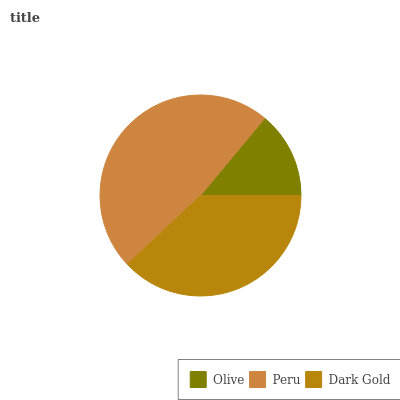Is Olive the minimum?
Answer yes or no. Yes. Is Peru the maximum?
Answer yes or no. Yes. Is Dark Gold the minimum?
Answer yes or no. No. Is Dark Gold the maximum?
Answer yes or no. No. Is Peru greater than Dark Gold?
Answer yes or no. Yes. Is Dark Gold less than Peru?
Answer yes or no. Yes. Is Dark Gold greater than Peru?
Answer yes or no. No. Is Peru less than Dark Gold?
Answer yes or no. No. Is Dark Gold the high median?
Answer yes or no. Yes. Is Dark Gold the low median?
Answer yes or no. Yes. Is Olive the high median?
Answer yes or no. No. Is Peru the low median?
Answer yes or no. No. 